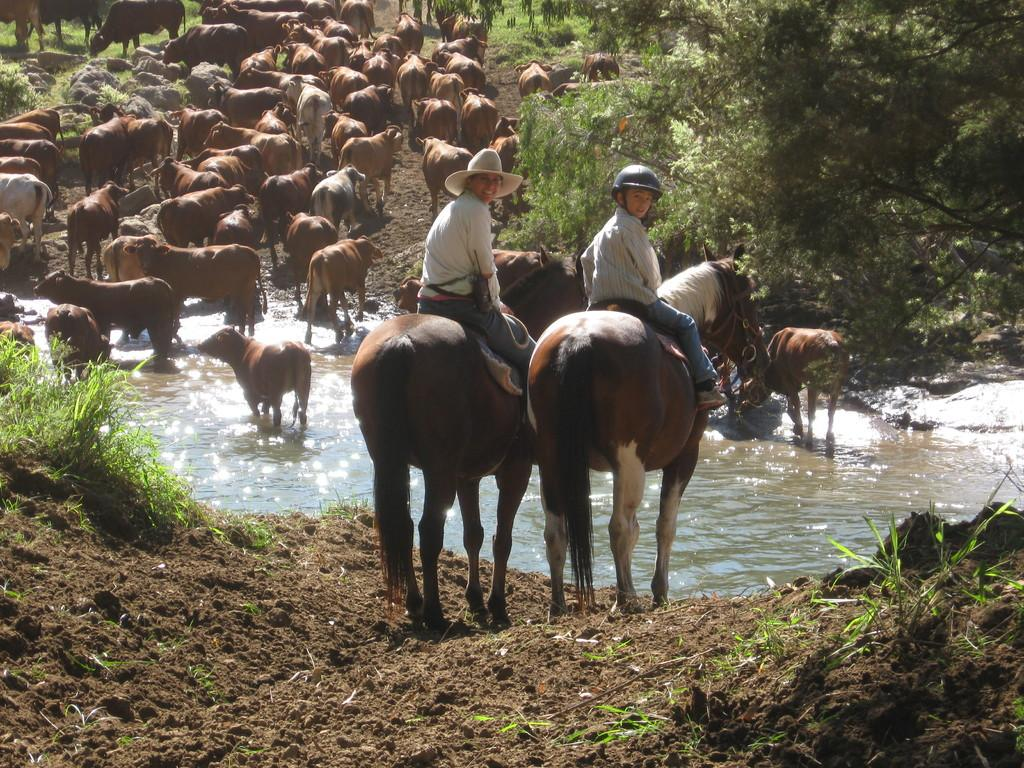What animals are present in the image? There is a herd of cows in the image. What are some of the cows doing in the image? Some cows are seated on horses. Are there any cows wearing accessories in the image? Yes, one cow is wearing a hat, and another cow is wearing a helmet. What type of vegetation can be seen in the image? Trees are present in the image. Can you describe the size of the giants in the image? There are no giants present in the image; it features a herd of cows. What type of nose can be seen on the cows in the image? Cows have snouts, not noses, but there is no specific detail about the snouts of the cows in the image. 